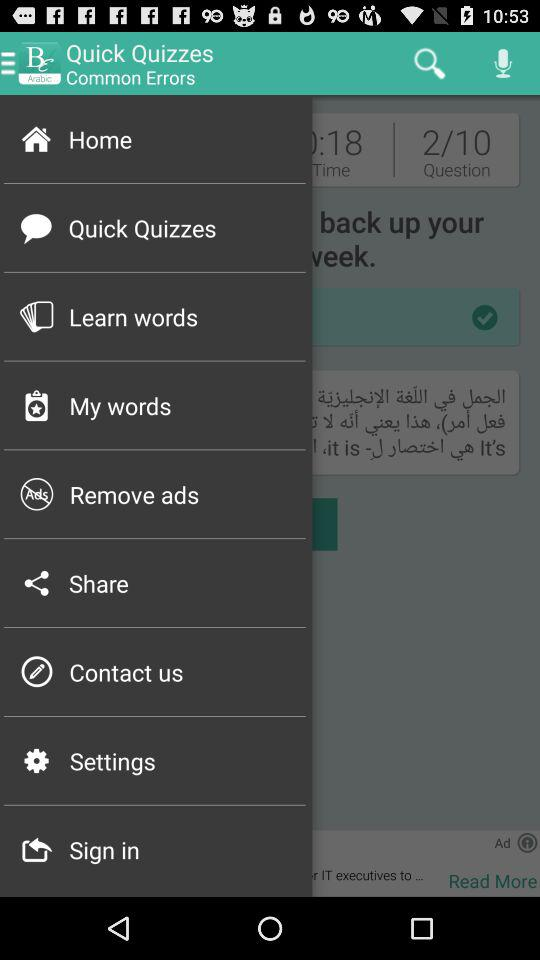What is the name of the application? The name of the application is "Britannica English". 